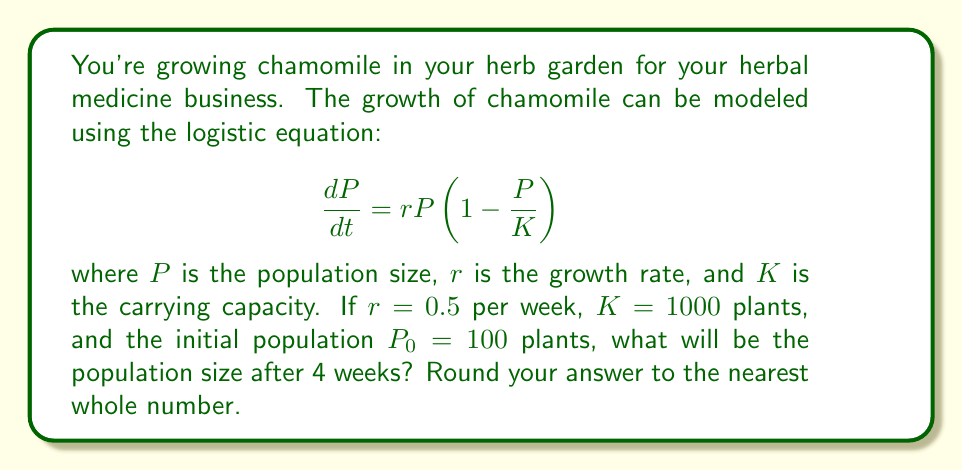Could you help me with this problem? To solve this problem, we'll use the solution to the logistic equation:

$$P(t) = \frac{K}{1 + (\frac{K}{P_0} - 1)e^{-rt}}$$

Let's follow these steps:

1) We're given:
   $r = 0.5$ per week
   $K = 1000$ plants
   $P_0 = 100$ plants
   $t = 4$ weeks

2) Substitute these values into the equation:

   $$P(4) = \frac{1000}{1 + (\frac{1000}{100} - 1)e^{-0.5(4)}}$$

3) Simplify:
   
   $$P(4) = \frac{1000}{1 + (10 - 1)e^{-2}}$$
   
   $$P(4) = \frac{1000}{1 + 9e^{-2}}$$

4) Calculate $e^{-2}$:
   
   $$e^{-2} \approx 0.1353$$

5) Substitute this value:

   $$P(4) = \frac{1000}{1 + 9(0.1353)}$$
   
   $$P(4) = \frac{1000}{1 + 1.2177}$$
   
   $$P(4) = \frac{1000}{2.2177}$$

6) Calculate the final result:

   $$P(4) \approx 450.92$$

7) Rounding to the nearest whole number:

   $$P(4) \approx 451$$
Answer: 451 plants 